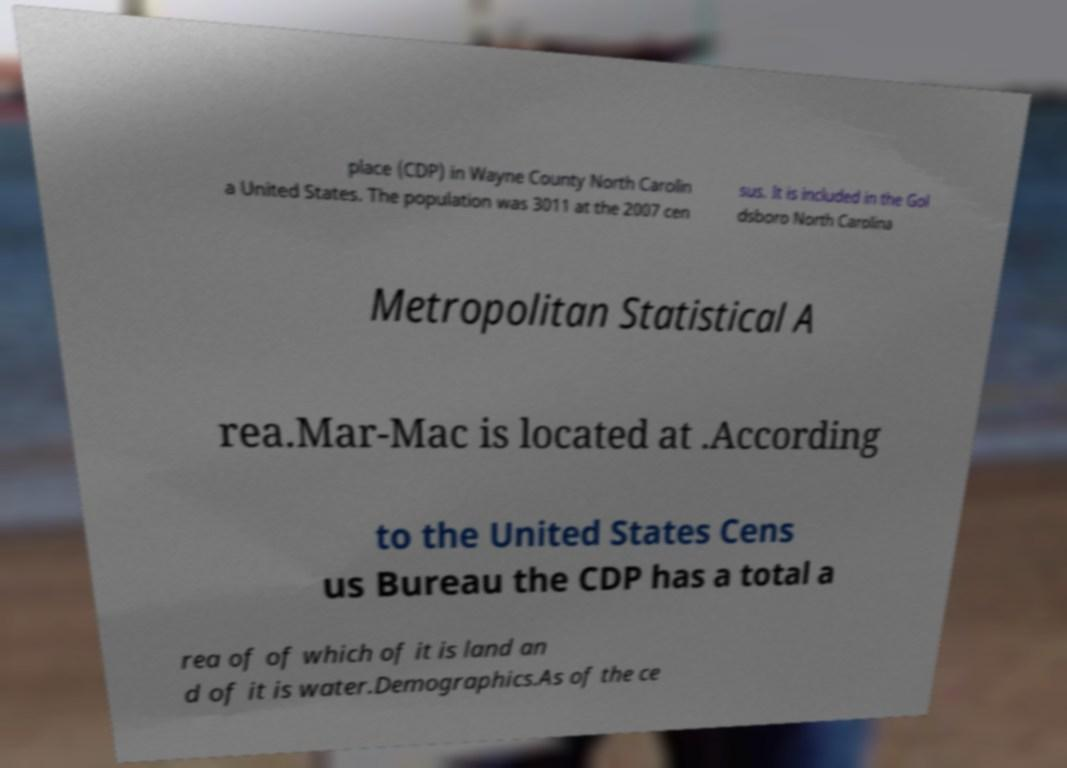Can you read and provide the text displayed in the image?This photo seems to have some interesting text. Can you extract and type it out for me? place (CDP) in Wayne County North Carolin a United States. The population was 3011 at the 2007 cen sus. It is included in the Gol dsboro North Carolina Metropolitan Statistical A rea.Mar-Mac is located at .According to the United States Cens us Bureau the CDP has a total a rea of of which of it is land an d of it is water.Demographics.As of the ce 